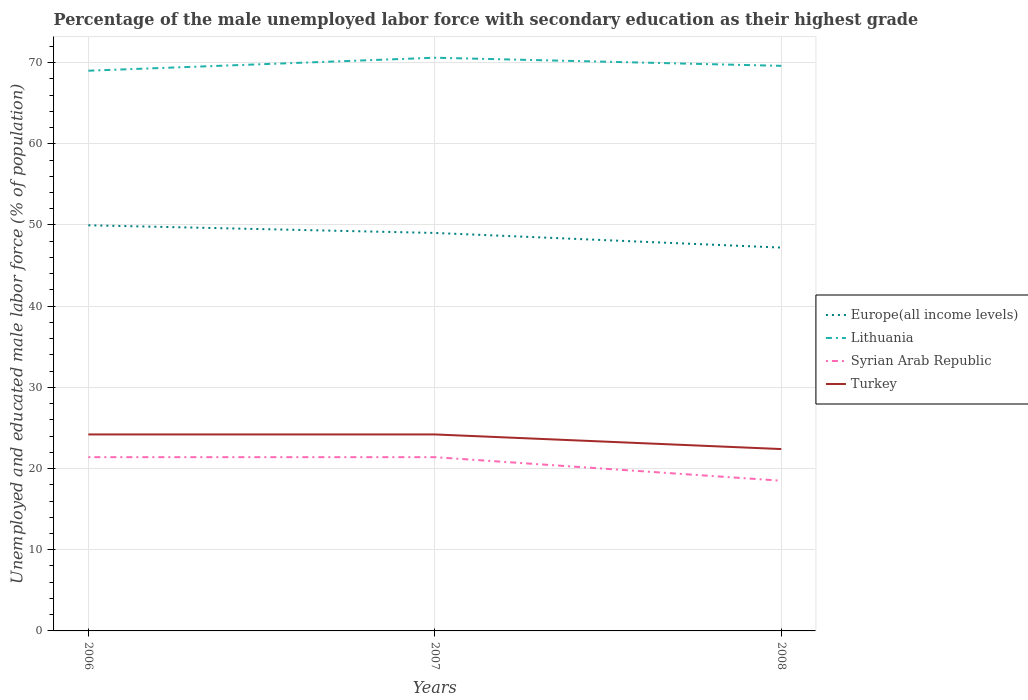Does the line corresponding to Lithuania intersect with the line corresponding to Turkey?
Your answer should be very brief. No. Is the number of lines equal to the number of legend labels?
Provide a short and direct response. Yes. What is the total percentage of the unemployed male labor force with secondary education in Europe(all income levels) in the graph?
Ensure brevity in your answer.  2.75. What is the difference between the highest and the second highest percentage of the unemployed male labor force with secondary education in Turkey?
Make the answer very short. 1.8. Is the percentage of the unemployed male labor force with secondary education in Lithuania strictly greater than the percentage of the unemployed male labor force with secondary education in Europe(all income levels) over the years?
Offer a terse response. No. Does the graph contain grids?
Ensure brevity in your answer.  Yes. Where does the legend appear in the graph?
Your response must be concise. Center right. What is the title of the graph?
Provide a short and direct response. Percentage of the male unemployed labor force with secondary education as their highest grade. Does "Lebanon" appear as one of the legend labels in the graph?
Your response must be concise. No. What is the label or title of the X-axis?
Give a very brief answer. Years. What is the label or title of the Y-axis?
Provide a succinct answer. Unemployed and educated male labor force (% of population). What is the Unemployed and educated male labor force (% of population) in Europe(all income levels) in 2006?
Keep it short and to the point. 49.97. What is the Unemployed and educated male labor force (% of population) in Syrian Arab Republic in 2006?
Keep it short and to the point. 21.4. What is the Unemployed and educated male labor force (% of population) in Turkey in 2006?
Your answer should be compact. 24.2. What is the Unemployed and educated male labor force (% of population) of Europe(all income levels) in 2007?
Give a very brief answer. 49.02. What is the Unemployed and educated male labor force (% of population) of Lithuania in 2007?
Give a very brief answer. 70.6. What is the Unemployed and educated male labor force (% of population) in Syrian Arab Republic in 2007?
Make the answer very short. 21.4. What is the Unemployed and educated male labor force (% of population) of Turkey in 2007?
Offer a terse response. 24.2. What is the Unemployed and educated male labor force (% of population) in Europe(all income levels) in 2008?
Keep it short and to the point. 47.21. What is the Unemployed and educated male labor force (% of population) in Lithuania in 2008?
Make the answer very short. 69.6. What is the Unemployed and educated male labor force (% of population) in Syrian Arab Republic in 2008?
Your response must be concise. 18.5. What is the Unemployed and educated male labor force (% of population) in Turkey in 2008?
Provide a short and direct response. 22.4. Across all years, what is the maximum Unemployed and educated male labor force (% of population) in Europe(all income levels)?
Offer a very short reply. 49.97. Across all years, what is the maximum Unemployed and educated male labor force (% of population) in Lithuania?
Give a very brief answer. 70.6. Across all years, what is the maximum Unemployed and educated male labor force (% of population) in Syrian Arab Republic?
Ensure brevity in your answer.  21.4. Across all years, what is the maximum Unemployed and educated male labor force (% of population) of Turkey?
Provide a succinct answer. 24.2. Across all years, what is the minimum Unemployed and educated male labor force (% of population) of Europe(all income levels)?
Ensure brevity in your answer.  47.21. Across all years, what is the minimum Unemployed and educated male labor force (% of population) of Turkey?
Ensure brevity in your answer.  22.4. What is the total Unemployed and educated male labor force (% of population) in Europe(all income levels) in the graph?
Your response must be concise. 146.2. What is the total Unemployed and educated male labor force (% of population) in Lithuania in the graph?
Keep it short and to the point. 209.2. What is the total Unemployed and educated male labor force (% of population) in Syrian Arab Republic in the graph?
Provide a short and direct response. 61.3. What is the total Unemployed and educated male labor force (% of population) of Turkey in the graph?
Offer a very short reply. 70.8. What is the difference between the Unemployed and educated male labor force (% of population) of Europe(all income levels) in 2006 and that in 2007?
Your answer should be compact. 0.95. What is the difference between the Unemployed and educated male labor force (% of population) of Lithuania in 2006 and that in 2007?
Your answer should be compact. -1.6. What is the difference between the Unemployed and educated male labor force (% of population) of Europe(all income levels) in 2006 and that in 2008?
Ensure brevity in your answer.  2.75. What is the difference between the Unemployed and educated male labor force (% of population) of Syrian Arab Republic in 2006 and that in 2008?
Keep it short and to the point. 2.9. What is the difference between the Unemployed and educated male labor force (% of population) in Europe(all income levels) in 2007 and that in 2008?
Provide a succinct answer. 1.8. What is the difference between the Unemployed and educated male labor force (% of population) in Lithuania in 2007 and that in 2008?
Give a very brief answer. 1. What is the difference between the Unemployed and educated male labor force (% of population) in Turkey in 2007 and that in 2008?
Your response must be concise. 1.8. What is the difference between the Unemployed and educated male labor force (% of population) of Europe(all income levels) in 2006 and the Unemployed and educated male labor force (% of population) of Lithuania in 2007?
Keep it short and to the point. -20.63. What is the difference between the Unemployed and educated male labor force (% of population) of Europe(all income levels) in 2006 and the Unemployed and educated male labor force (% of population) of Syrian Arab Republic in 2007?
Make the answer very short. 28.57. What is the difference between the Unemployed and educated male labor force (% of population) of Europe(all income levels) in 2006 and the Unemployed and educated male labor force (% of population) of Turkey in 2007?
Make the answer very short. 25.77. What is the difference between the Unemployed and educated male labor force (% of population) of Lithuania in 2006 and the Unemployed and educated male labor force (% of population) of Syrian Arab Republic in 2007?
Make the answer very short. 47.6. What is the difference between the Unemployed and educated male labor force (% of population) of Lithuania in 2006 and the Unemployed and educated male labor force (% of population) of Turkey in 2007?
Your response must be concise. 44.8. What is the difference between the Unemployed and educated male labor force (% of population) of Syrian Arab Republic in 2006 and the Unemployed and educated male labor force (% of population) of Turkey in 2007?
Your response must be concise. -2.8. What is the difference between the Unemployed and educated male labor force (% of population) in Europe(all income levels) in 2006 and the Unemployed and educated male labor force (% of population) in Lithuania in 2008?
Keep it short and to the point. -19.63. What is the difference between the Unemployed and educated male labor force (% of population) in Europe(all income levels) in 2006 and the Unemployed and educated male labor force (% of population) in Syrian Arab Republic in 2008?
Keep it short and to the point. 31.47. What is the difference between the Unemployed and educated male labor force (% of population) of Europe(all income levels) in 2006 and the Unemployed and educated male labor force (% of population) of Turkey in 2008?
Offer a very short reply. 27.57. What is the difference between the Unemployed and educated male labor force (% of population) of Lithuania in 2006 and the Unemployed and educated male labor force (% of population) of Syrian Arab Republic in 2008?
Make the answer very short. 50.5. What is the difference between the Unemployed and educated male labor force (% of population) of Lithuania in 2006 and the Unemployed and educated male labor force (% of population) of Turkey in 2008?
Make the answer very short. 46.6. What is the difference between the Unemployed and educated male labor force (% of population) in Syrian Arab Republic in 2006 and the Unemployed and educated male labor force (% of population) in Turkey in 2008?
Offer a terse response. -1. What is the difference between the Unemployed and educated male labor force (% of population) of Europe(all income levels) in 2007 and the Unemployed and educated male labor force (% of population) of Lithuania in 2008?
Offer a terse response. -20.58. What is the difference between the Unemployed and educated male labor force (% of population) in Europe(all income levels) in 2007 and the Unemployed and educated male labor force (% of population) in Syrian Arab Republic in 2008?
Keep it short and to the point. 30.52. What is the difference between the Unemployed and educated male labor force (% of population) in Europe(all income levels) in 2007 and the Unemployed and educated male labor force (% of population) in Turkey in 2008?
Provide a short and direct response. 26.62. What is the difference between the Unemployed and educated male labor force (% of population) of Lithuania in 2007 and the Unemployed and educated male labor force (% of population) of Syrian Arab Republic in 2008?
Your answer should be compact. 52.1. What is the difference between the Unemployed and educated male labor force (% of population) of Lithuania in 2007 and the Unemployed and educated male labor force (% of population) of Turkey in 2008?
Your answer should be very brief. 48.2. What is the average Unemployed and educated male labor force (% of population) of Europe(all income levels) per year?
Give a very brief answer. 48.73. What is the average Unemployed and educated male labor force (% of population) in Lithuania per year?
Make the answer very short. 69.73. What is the average Unemployed and educated male labor force (% of population) in Syrian Arab Republic per year?
Ensure brevity in your answer.  20.43. What is the average Unemployed and educated male labor force (% of population) in Turkey per year?
Provide a succinct answer. 23.6. In the year 2006, what is the difference between the Unemployed and educated male labor force (% of population) in Europe(all income levels) and Unemployed and educated male labor force (% of population) in Lithuania?
Make the answer very short. -19.03. In the year 2006, what is the difference between the Unemployed and educated male labor force (% of population) of Europe(all income levels) and Unemployed and educated male labor force (% of population) of Syrian Arab Republic?
Offer a very short reply. 28.57. In the year 2006, what is the difference between the Unemployed and educated male labor force (% of population) in Europe(all income levels) and Unemployed and educated male labor force (% of population) in Turkey?
Make the answer very short. 25.77. In the year 2006, what is the difference between the Unemployed and educated male labor force (% of population) of Lithuania and Unemployed and educated male labor force (% of population) of Syrian Arab Republic?
Give a very brief answer. 47.6. In the year 2006, what is the difference between the Unemployed and educated male labor force (% of population) in Lithuania and Unemployed and educated male labor force (% of population) in Turkey?
Offer a terse response. 44.8. In the year 2006, what is the difference between the Unemployed and educated male labor force (% of population) of Syrian Arab Republic and Unemployed and educated male labor force (% of population) of Turkey?
Offer a very short reply. -2.8. In the year 2007, what is the difference between the Unemployed and educated male labor force (% of population) of Europe(all income levels) and Unemployed and educated male labor force (% of population) of Lithuania?
Ensure brevity in your answer.  -21.58. In the year 2007, what is the difference between the Unemployed and educated male labor force (% of population) in Europe(all income levels) and Unemployed and educated male labor force (% of population) in Syrian Arab Republic?
Offer a terse response. 27.62. In the year 2007, what is the difference between the Unemployed and educated male labor force (% of population) in Europe(all income levels) and Unemployed and educated male labor force (% of population) in Turkey?
Ensure brevity in your answer.  24.82. In the year 2007, what is the difference between the Unemployed and educated male labor force (% of population) in Lithuania and Unemployed and educated male labor force (% of population) in Syrian Arab Republic?
Provide a short and direct response. 49.2. In the year 2007, what is the difference between the Unemployed and educated male labor force (% of population) in Lithuania and Unemployed and educated male labor force (% of population) in Turkey?
Provide a short and direct response. 46.4. In the year 2008, what is the difference between the Unemployed and educated male labor force (% of population) in Europe(all income levels) and Unemployed and educated male labor force (% of population) in Lithuania?
Offer a terse response. -22.39. In the year 2008, what is the difference between the Unemployed and educated male labor force (% of population) of Europe(all income levels) and Unemployed and educated male labor force (% of population) of Syrian Arab Republic?
Your response must be concise. 28.71. In the year 2008, what is the difference between the Unemployed and educated male labor force (% of population) in Europe(all income levels) and Unemployed and educated male labor force (% of population) in Turkey?
Make the answer very short. 24.81. In the year 2008, what is the difference between the Unemployed and educated male labor force (% of population) in Lithuania and Unemployed and educated male labor force (% of population) in Syrian Arab Republic?
Ensure brevity in your answer.  51.1. In the year 2008, what is the difference between the Unemployed and educated male labor force (% of population) in Lithuania and Unemployed and educated male labor force (% of population) in Turkey?
Provide a short and direct response. 47.2. What is the ratio of the Unemployed and educated male labor force (% of population) in Europe(all income levels) in 2006 to that in 2007?
Your answer should be very brief. 1.02. What is the ratio of the Unemployed and educated male labor force (% of population) in Lithuania in 2006 to that in 2007?
Keep it short and to the point. 0.98. What is the ratio of the Unemployed and educated male labor force (% of population) in Syrian Arab Republic in 2006 to that in 2007?
Your answer should be very brief. 1. What is the ratio of the Unemployed and educated male labor force (% of population) in Europe(all income levels) in 2006 to that in 2008?
Your answer should be very brief. 1.06. What is the ratio of the Unemployed and educated male labor force (% of population) in Lithuania in 2006 to that in 2008?
Your response must be concise. 0.99. What is the ratio of the Unemployed and educated male labor force (% of population) of Syrian Arab Republic in 2006 to that in 2008?
Your answer should be compact. 1.16. What is the ratio of the Unemployed and educated male labor force (% of population) in Turkey in 2006 to that in 2008?
Give a very brief answer. 1.08. What is the ratio of the Unemployed and educated male labor force (% of population) in Europe(all income levels) in 2007 to that in 2008?
Provide a succinct answer. 1.04. What is the ratio of the Unemployed and educated male labor force (% of population) of Lithuania in 2007 to that in 2008?
Offer a very short reply. 1.01. What is the ratio of the Unemployed and educated male labor force (% of population) of Syrian Arab Republic in 2007 to that in 2008?
Ensure brevity in your answer.  1.16. What is the ratio of the Unemployed and educated male labor force (% of population) in Turkey in 2007 to that in 2008?
Your answer should be compact. 1.08. What is the difference between the highest and the second highest Unemployed and educated male labor force (% of population) in Europe(all income levels)?
Your answer should be very brief. 0.95. What is the difference between the highest and the second highest Unemployed and educated male labor force (% of population) of Syrian Arab Republic?
Provide a succinct answer. 0. What is the difference between the highest and the second highest Unemployed and educated male labor force (% of population) in Turkey?
Offer a terse response. 0. What is the difference between the highest and the lowest Unemployed and educated male labor force (% of population) in Europe(all income levels)?
Provide a succinct answer. 2.75. What is the difference between the highest and the lowest Unemployed and educated male labor force (% of population) of Lithuania?
Provide a succinct answer. 1.6. What is the difference between the highest and the lowest Unemployed and educated male labor force (% of population) in Syrian Arab Republic?
Provide a succinct answer. 2.9. 